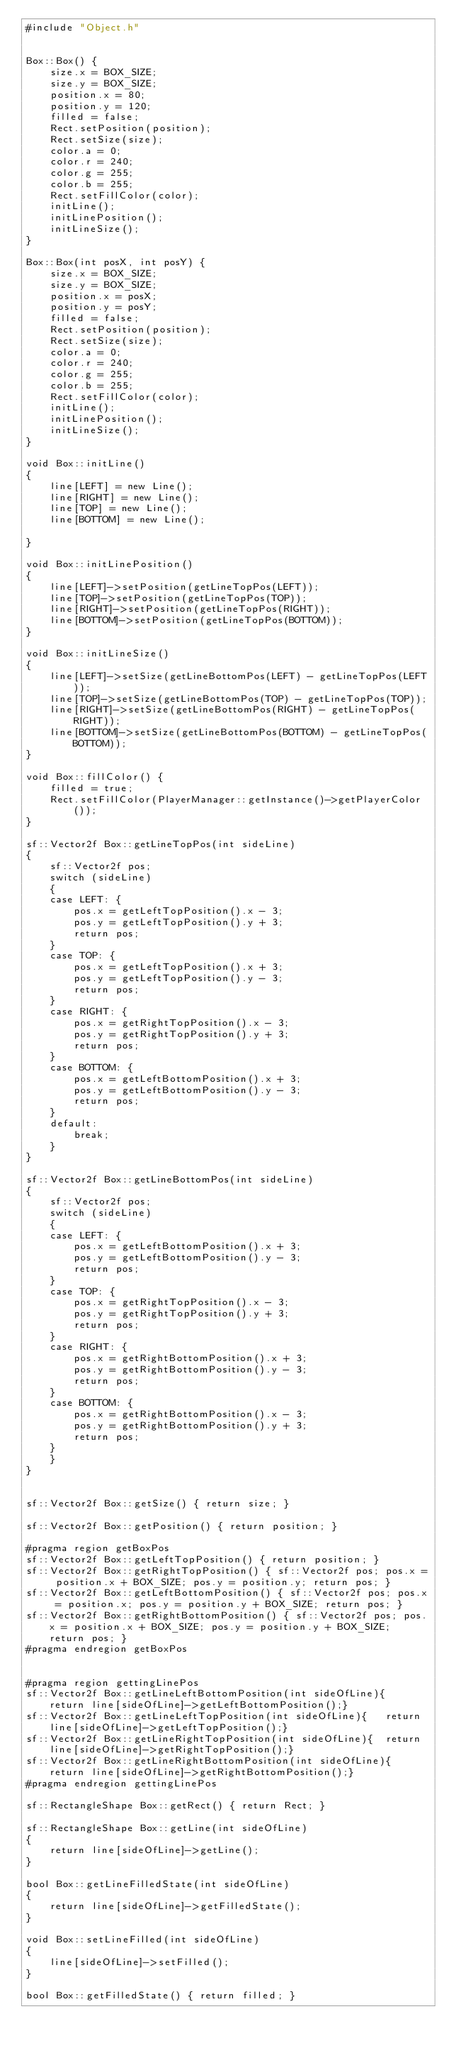<code> <loc_0><loc_0><loc_500><loc_500><_C++_>#include "Object.h"


Box::Box() {
	size.x = BOX_SIZE;
	size.y = BOX_SIZE;
	position.x = 80;
	position.y = 120;
	filled = false;
	Rect.setPosition(position);
	Rect.setSize(size);
	color.a = 0;
	color.r = 240;
	color.g = 255;
	color.b = 255;
	Rect.setFillColor(color);
	initLine();
	initLinePosition();
	initLineSize();
}

Box::Box(int posX, int posY) {
	size.x = BOX_SIZE;
	size.y = BOX_SIZE;
	position.x = posX;
	position.y = posY;
	filled = false;
	Rect.setPosition(position);
	Rect.setSize(size);
	color.a = 0;
	color.r = 240;
	color.g = 255;
	color.b = 255;
	Rect.setFillColor(color);
	initLine();
	initLinePosition();
	initLineSize();
}

void Box::initLine()
{
	line[LEFT] = new Line();
	line[RIGHT] = new Line();
	line[TOP] = new Line();
	line[BOTTOM] = new Line();

}

void Box::initLinePosition()
{
	line[LEFT]->setPosition(getLineTopPos(LEFT));
	line[TOP]->setPosition(getLineTopPos(TOP));
	line[RIGHT]->setPosition(getLineTopPos(RIGHT));
	line[BOTTOM]->setPosition(getLineTopPos(BOTTOM));
}

void Box::initLineSize()
{
	line[LEFT]->setSize(getLineBottomPos(LEFT) - getLineTopPos(LEFT));
	line[TOP]->setSize(getLineBottomPos(TOP) - getLineTopPos(TOP));
	line[RIGHT]->setSize(getLineBottomPos(RIGHT) - getLineTopPos(RIGHT));
	line[BOTTOM]->setSize(getLineBottomPos(BOTTOM) - getLineTopPos(BOTTOM));
}

void Box::fillColor() {
	filled = true;
	Rect.setFillColor(PlayerManager::getInstance()->getPlayerColor());
}

sf::Vector2f Box::getLineTopPos(int sideLine)
{
	sf::Vector2f pos;
	switch (sideLine)
	{
	case LEFT: {
		pos.x = getLeftTopPosition().x - 3;
		pos.y = getLeftTopPosition().y + 3;
		return pos;
	}
	case TOP: {
		pos.x = getLeftTopPosition().x + 3;
		pos.y = getLeftTopPosition().y - 3;
		return pos;
	}
	case RIGHT: {
		pos.x = getRightTopPosition().x - 3;
		pos.y = getRightTopPosition().y + 3;
		return pos;
	}
	case BOTTOM: {
		pos.x = getLeftBottomPosition().x + 3;
		pos.y = getLeftBottomPosition().y - 3;
		return pos;
	}
	default:
		break;
	}
}

sf::Vector2f Box::getLineBottomPos(int sideLine)
{
	sf::Vector2f pos;
	switch (sideLine)
	{
	case LEFT: {
		pos.x = getLeftBottomPosition().x + 3;
		pos.y = getLeftBottomPosition().y - 3;
		return pos;
	}
	case TOP: {
		pos.x = getRightTopPosition().x - 3;
		pos.y = getRightTopPosition().y + 3;
		return pos;
	}
	case RIGHT: {
		pos.x = getRightBottomPosition().x + 3;
		pos.y = getRightBottomPosition().y - 3;
		return pos;
	}
	case BOTTOM: {
		pos.x = getRightBottomPosition().x - 3;
		pos.y = getRightBottomPosition().y + 3;
		return pos;
	}
	}
}


sf::Vector2f Box::getSize() { return size; }

sf::Vector2f Box::getPosition() { return position; }

#pragma region getBoxPos
sf::Vector2f Box::getLeftTopPosition() { return position; }
sf::Vector2f Box::getRightTopPosition() { sf::Vector2f pos; pos.x = position.x + BOX_SIZE; pos.y = position.y; return pos; }
sf::Vector2f Box::getLeftBottomPosition() { sf::Vector2f pos; pos.x = position.x; pos.y = position.y + BOX_SIZE; return pos; }
sf::Vector2f Box::getRightBottomPosition() { sf::Vector2f pos; pos.x = position.x + BOX_SIZE; pos.y = position.y + BOX_SIZE; return pos; }
#pragma endregion getBoxPos


#pragma region gettingLinePos
sf::Vector2f Box::getLineLeftBottomPosition(int sideOfLine){	return line[sideOfLine]->getLeftBottomPosition();}
sf::Vector2f Box::getLineLeftTopPosition(int sideOfLine){	return line[sideOfLine]->getLeftTopPosition();}
sf::Vector2f Box::getLineRightTopPosition(int sideOfLine){	return line[sideOfLine]->getRightTopPosition();}
sf::Vector2f Box::getLineRightBottomPosition(int sideOfLine){	return line[sideOfLine]->getRightBottomPosition();}
#pragma endregion gettingLinePos

sf::RectangleShape Box::getRect() {	return Rect; }

sf::RectangleShape Box::getLine(int sideOfLine)
{
	return line[sideOfLine]->getLine();
}

bool Box::getLineFilledState(int sideOfLine)
{
	return line[sideOfLine]->getFilledState();
}

void Box::setLineFilled(int sideOfLine)
{
	line[sideOfLine]->setFilled();
}

bool Box::getFilledState() { return filled; }
</code> 